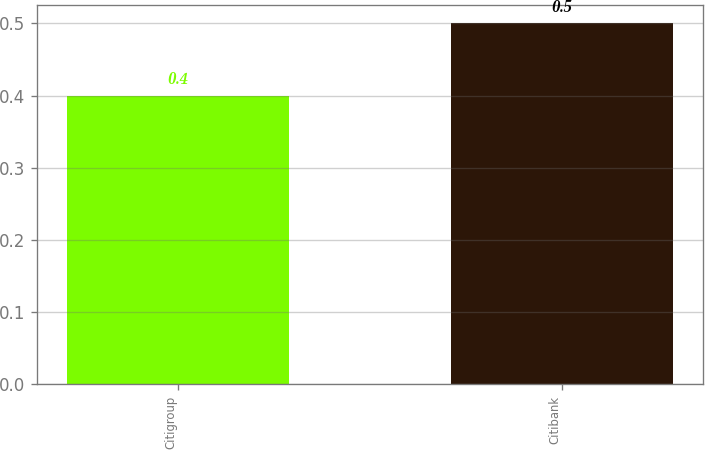Convert chart to OTSL. <chart><loc_0><loc_0><loc_500><loc_500><bar_chart><fcel>Citigroup<fcel>Citibank<nl><fcel>0.4<fcel>0.5<nl></chart> 